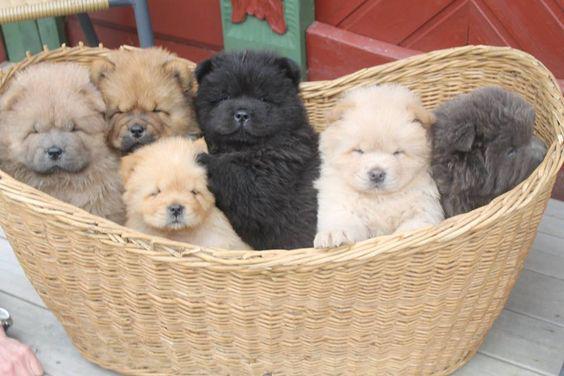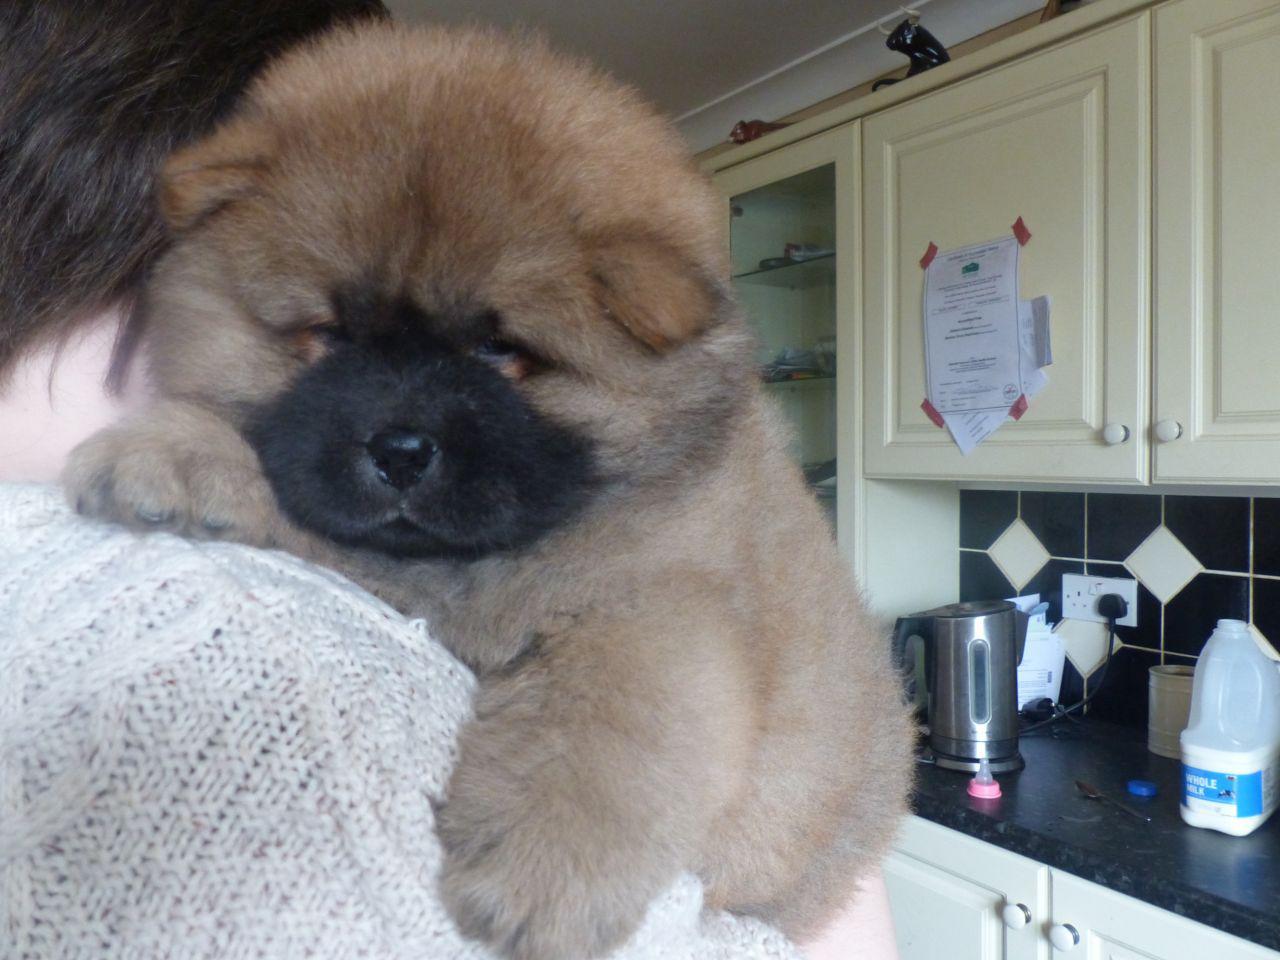The first image is the image on the left, the second image is the image on the right. Given the left and right images, does the statement "In one image, a woman poses with three dogs" hold true? Answer yes or no. No. The first image is the image on the left, the second image is the image on the right. Analyze the images presented: Is the assertion "There is at least one cream colored Chow Chow puppy in the image on the left." valid? Answer yes or no. Yes. 